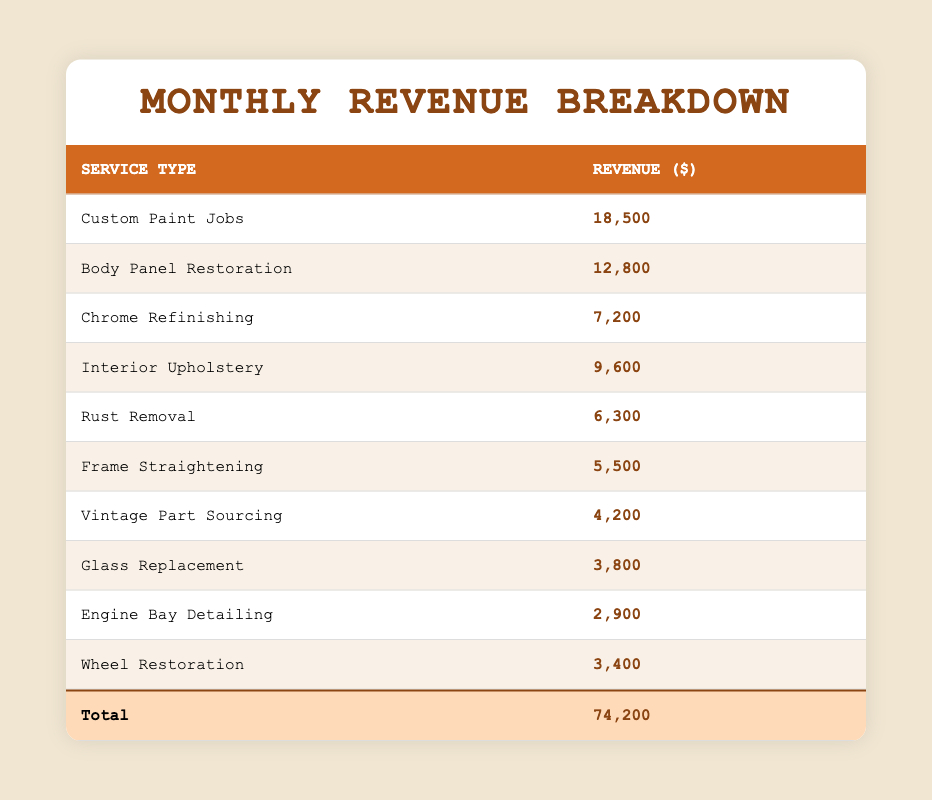What is the total revenue from all service types? To find the total revenue, we add up the values from all service types: 18500 + 12800 + 7200 + 9600 + 6300 + 5500 + 4200 + 3800 + 2900 + 3400 = 74200.
Answer: 74200 Which service type generated the highest revenue? Looking at the revenue figures, Custom Paint Jobs has the highest revenue at 18500.
Answer: Custom Paint Jobs Is the revenue from Rust Removal greater than the revenue from Frame Straightening? Rust Removal has a revenue of 6300 and Frame Straightening has a revenue of 5500. Since 6300 is greater than 5500, the statement is true.
Answer: Yes What is the difference in revenue between Body Panel Restoration and Chrome Refinishing? The revenue for Body Panel Restoration is 12800 and for Chrome Refinishing it is 7200. The difference is 12800 - 7200 = 5600.
Answer: 5600 What percentage of the total revenue comes from Vintage Part Sourcing? The revenue from Vintage Part Sourcing is 4200. To find the percentage, we calculate (4200 / 74200) * 100, which is approximately 5.65%.
Answer: 5.65% Are there more services with revenue above 5000 or below 5000? Listing the services with revenue above 5000: Custom Paint Jobs, Body Panel Restoration, Chrome Refinishing, Interior Upholstery, Rust Removal, Frame Straightening (6 services). Below 5000: Vintage Part Sourcing, Glass Replacement, Engine Bay Detailing, Wheel Restoration (4 services). So, there are more services above 5000.
Answer: Yes What is the average revenue from all service types? To find the average, we sum the revenues (74200) and divide by the number of services (10): 74200 / 10 = 7420.
Answer: 7420 Which service types have revenue less than 5000? The services that have revenue less than 5000 are Vintage Part Sourcing (4200), Glass Replacement (3800), Engine Bay Detailing (2900), and Wheel Restoration (3400). Count these services to find that there are 4 services below 5000.
Answer: 4 